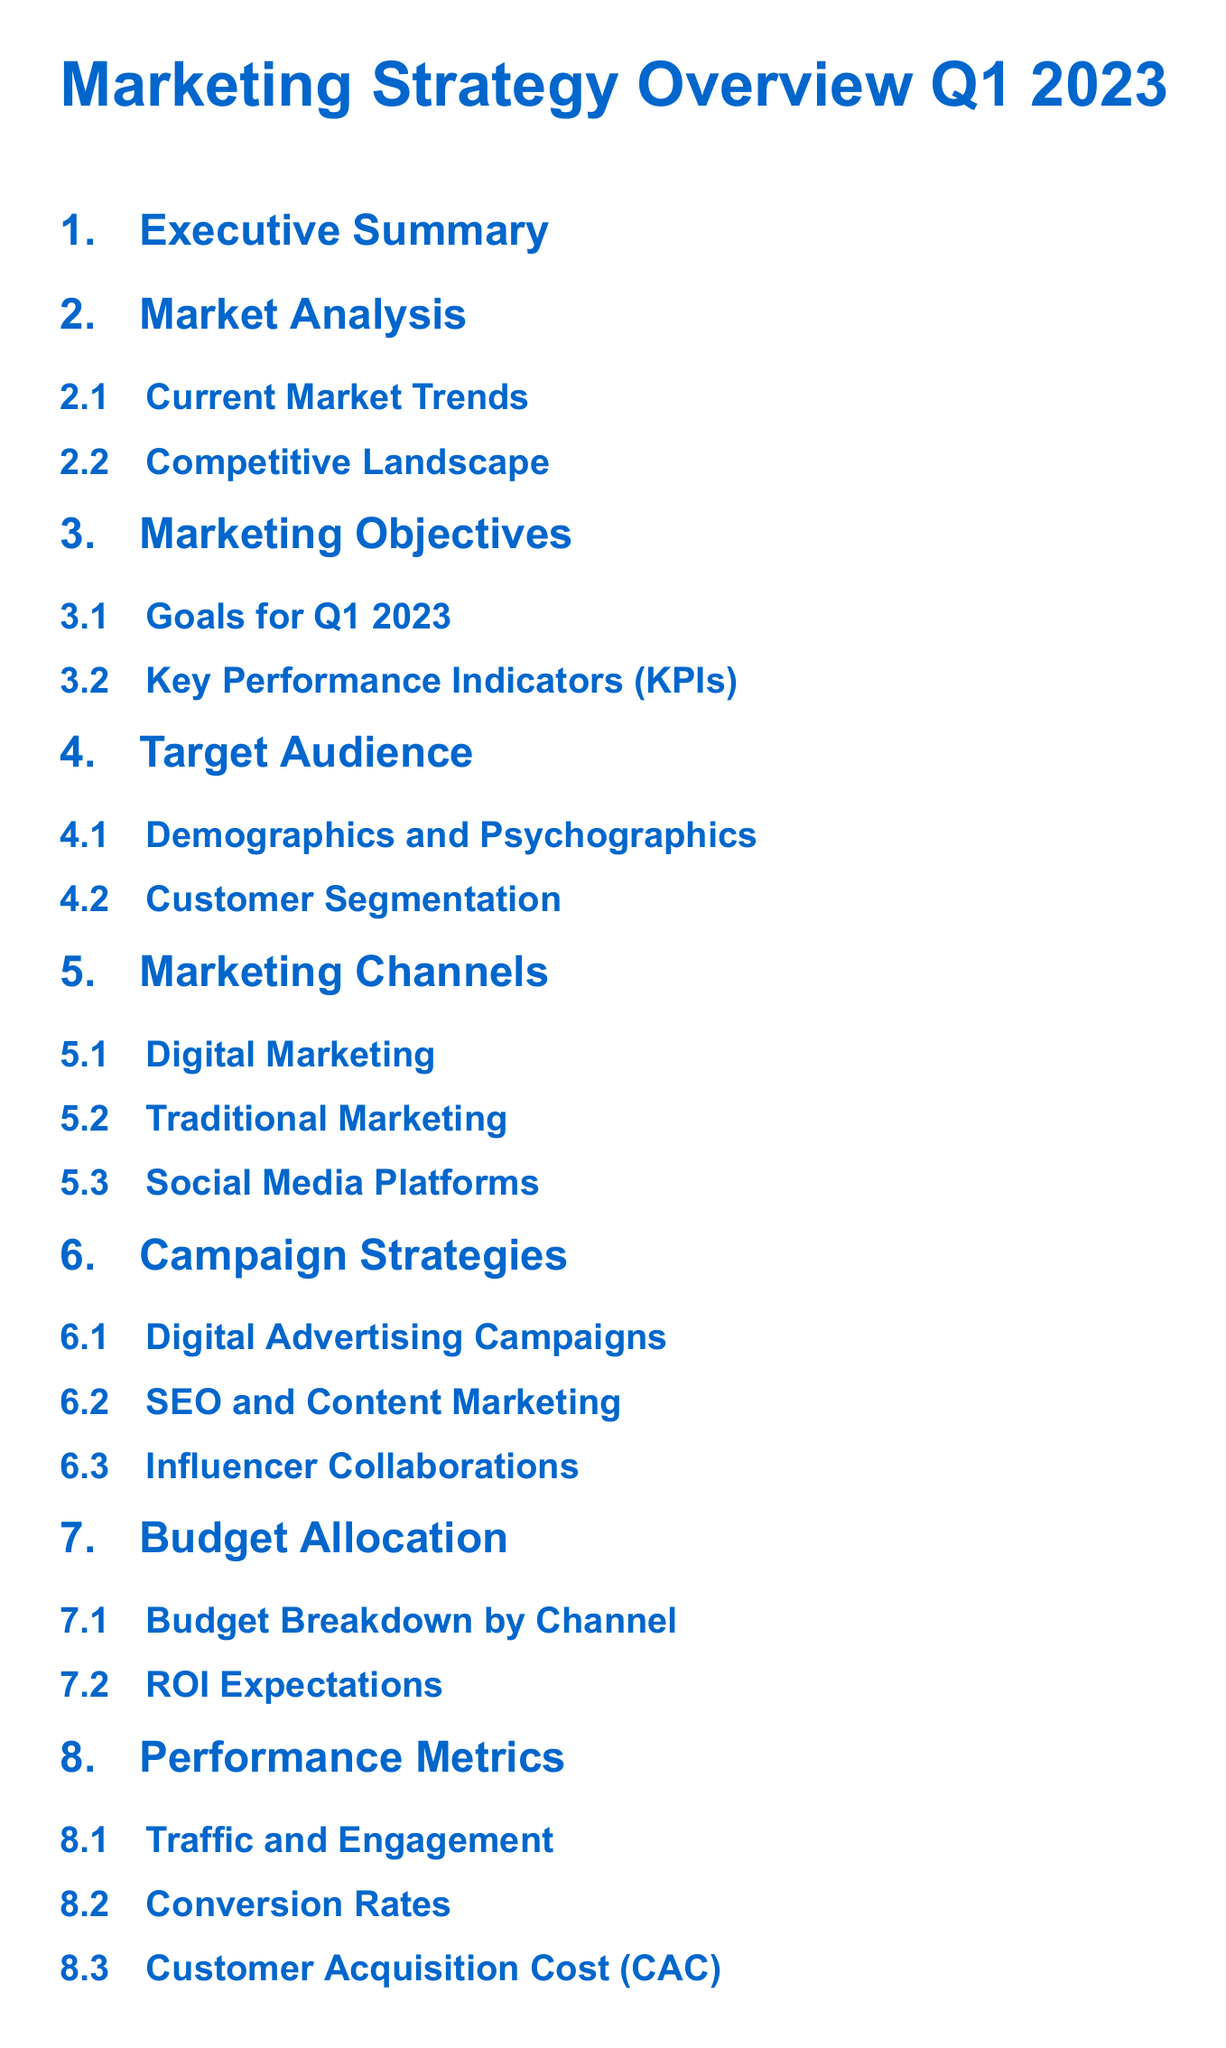what is the title of the document? The title is indicated at the top of the Table of Contents.
Answer: Marketing Strategy Overview Q1 2023 how many subsections are in the Campaign Strategies section? The number of subsections can be counted in the document.
Answer: 3 what is one of the Key Performance Indicators listed? The specific KPIs are outlined in the Marketing Objectives section.
Answer: Key Performance Indicators (KPIs) what does the Performance Metrics section include? The section covers various metrics related to performance measurement.
Answer: Traffic and Engagement what is the last section of the document? The order of sections can be observed in the Table of Contents.
Answer: Conclusion what is a strategy mentioned under Campaign Strategies? The strategies provided within that section can be referenced.
Answer: Digital Advertising Campaigns how many marketing channels are listed? The total number of channels can be identified in the Marketing Channels section.
Answer: 3 what is the focus of the Executive Summary section? The summary typically highlights key insights and conclusions from the document.
Answer: Executive Summary what does the Budget Allocation section analyze? The Budget Allocation section specifically discusses financial aspects of the marketing strategy.
Answer: Budget Breakdown by Channel 